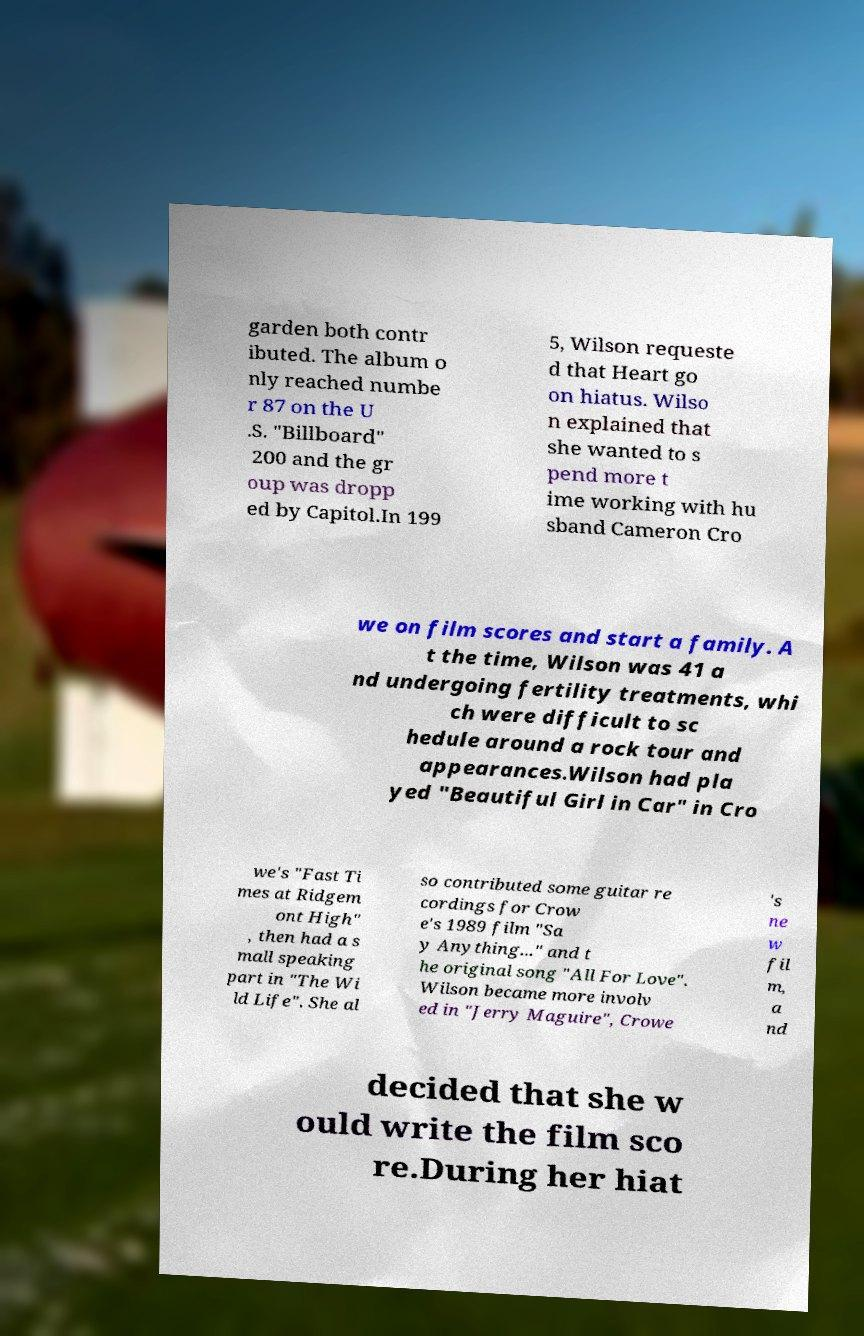Can you read and provide the text displayed in the image?This photo seems to have some interesting text. Can you extract and type it out for me? garden both contr ibuted. The album o nly reached numbe r 87 on the U .S. "Billboard" 200 and the gr oup was dropp ed by Capitol.In 199 5, Wilson requeste d that Heart go on hiatus. Wilso n explained that she wanted to s pend more t ime working with hu sband Cameron Cro we on film scores and start a family. A t the time, Wilson was 41 a nd undergoing fertility treatments, whi ch were difficult to sc hedule around a rock tour and appearances.Wilson had pla yed "Beautiful Girl in Car" in Cro we's "Fast Ti mes at Ridgem ont High" , then had a s mall speaking part in "The Wi ld Life". She al so contributed some guitar re cordings for Crow e's 1989 film "Sa y Anything..." and t he original song "All For Love". Wilson became more involv ed in "Jerry Maguire", Crowe 's ne w fil m, a nd decided that she w ould write the film sco re.During her hiat 